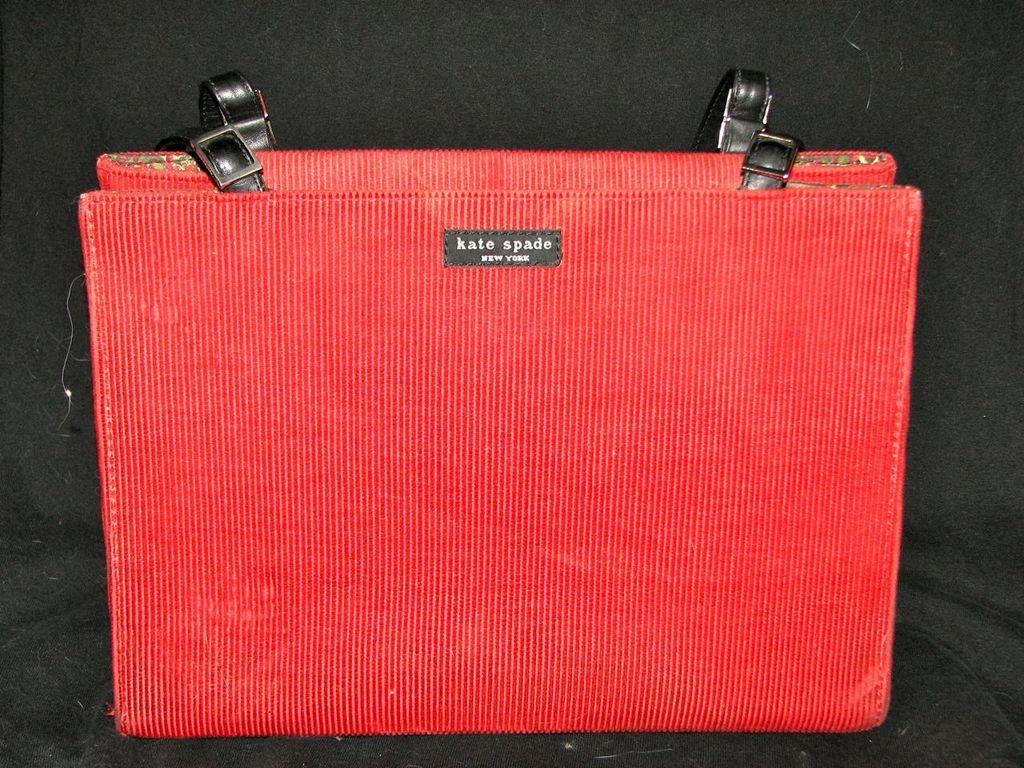Describe this image in one or two sentences. In this image there is red colour bag. In the background there is a black colour sofa. on the bag we can read as Kate spade. 